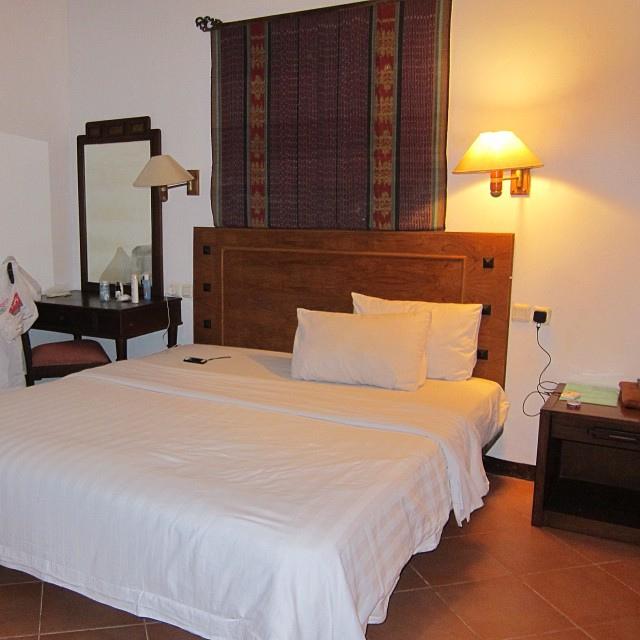How many lights are turned on?
Keep it brief. 1. Is there a tapestry in the image?
Quick response, please. Yes. What color is the blanket?
Be succinct. White. What color are the lights?
Be succinct. Yellow. 